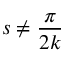<formula> <loc_0><loc_0><loc_500><loc_500>s \neq { \frac { \pi } { 2 k } }</formula> 